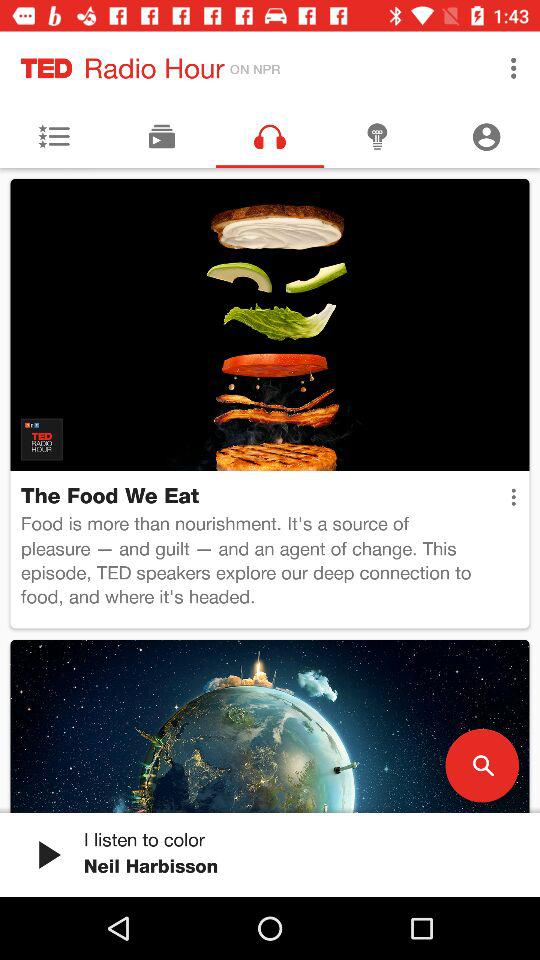What is the name of the application? The name of the application is "TED Radio Hour". 